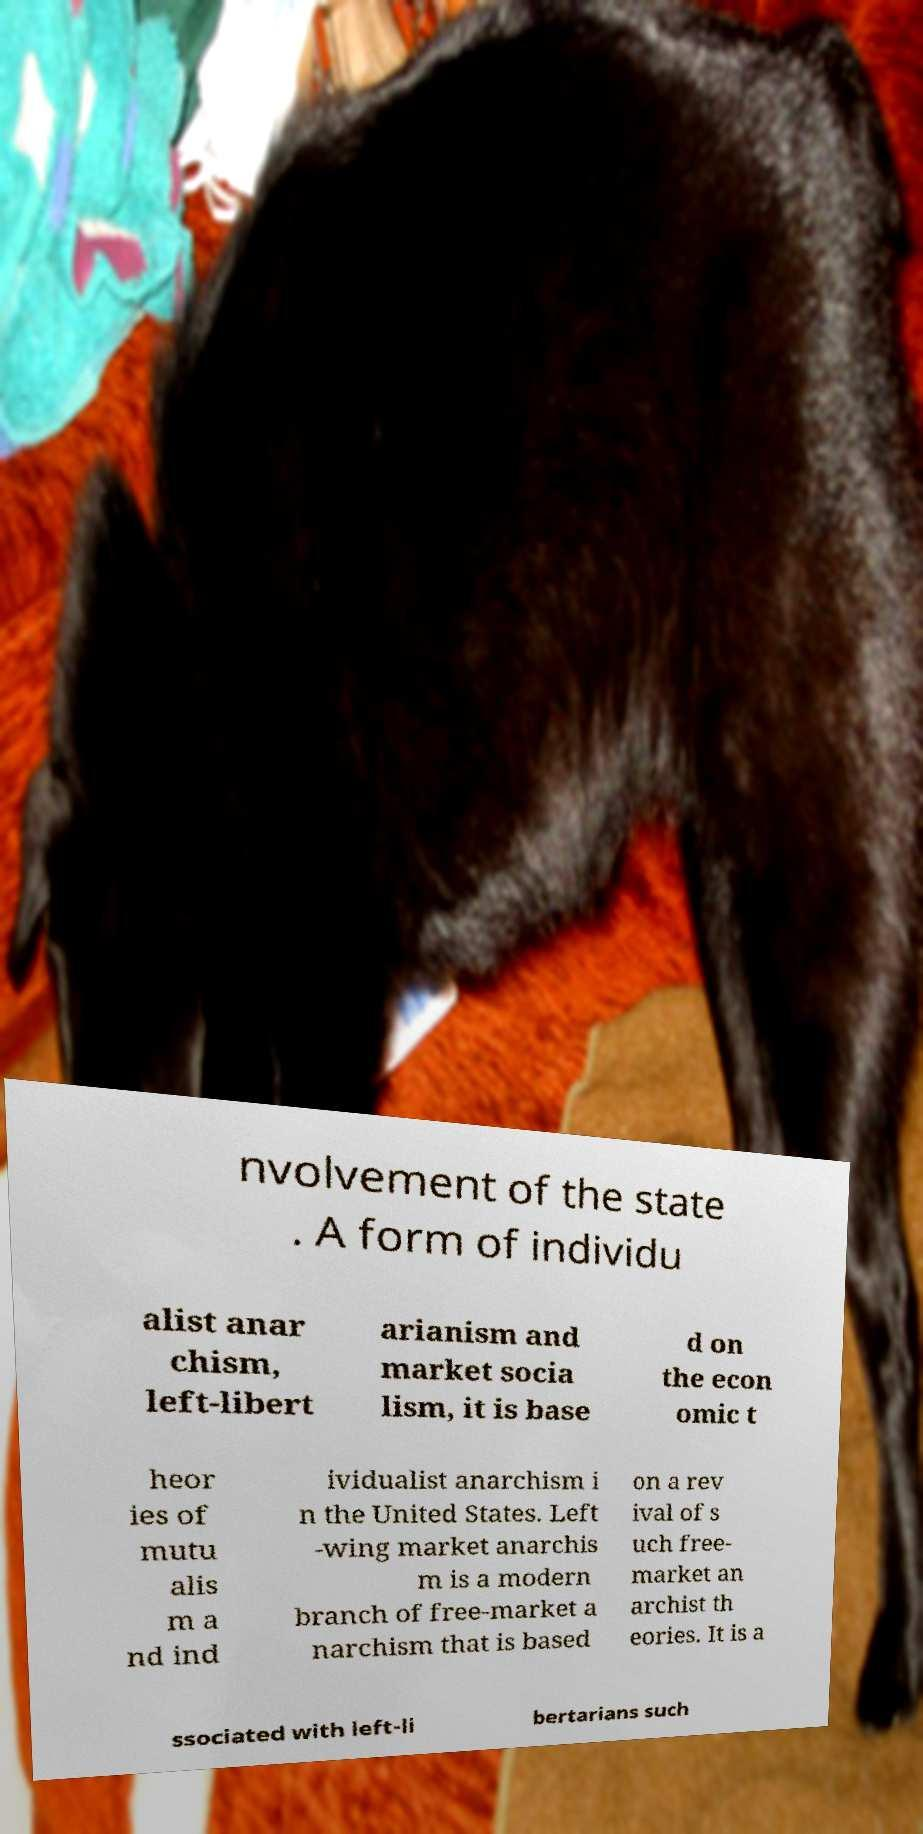For documentation purposes, I need the text within this image transcribed. Could you provide that? nvolvement of the state . A form of individu alist anar chism, left-libert arianism and market socia lism, it is base d on the econ omic t heor ies of mutu alis m a nd ind ividualist anarchism i n the United States. Left -wing market anarchis m is a modern branch of free-market a narchism that is based on a rev ival of s uch free- market an archist th eories. It is a ssociated with left-li bertarians such 